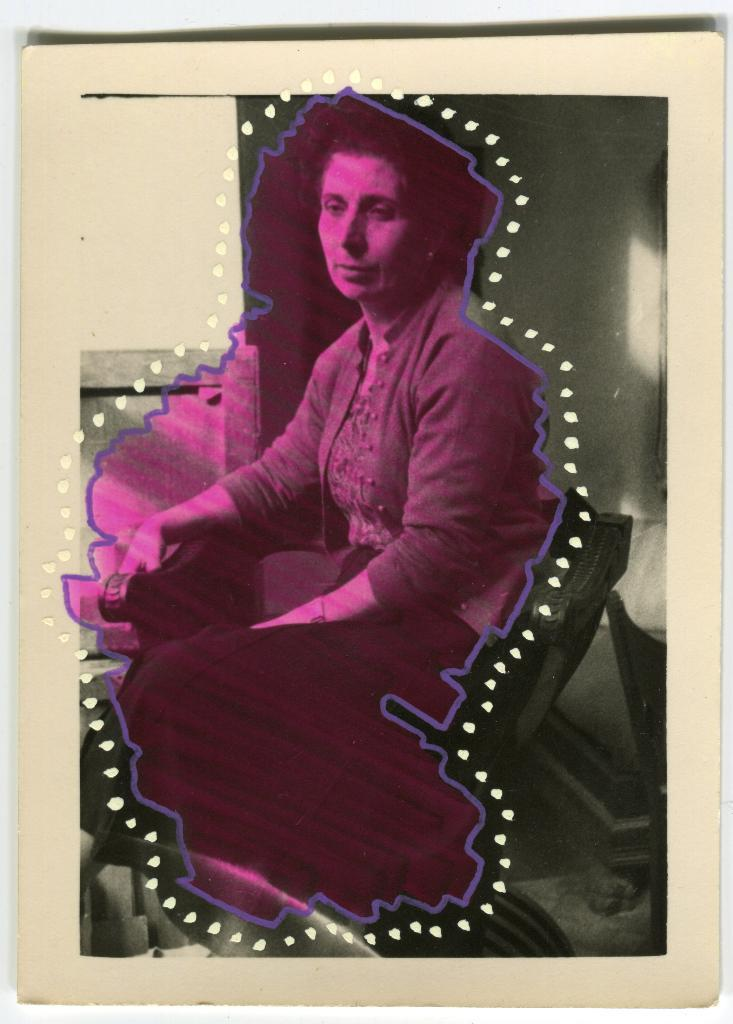What is the main subject of the image? The main subject of the image is a person. Can you describe the person in the image? The person is a woman. What is the woman doing in the image? The woman is sitting on a chair. What can be seen in the background of the image? There is a wall in the background of the image. What type of sweater is the woman wearing in the image? There is no mention of a sweater in the image, so it cannot be determined what type of sweater the woman might be wearing. 